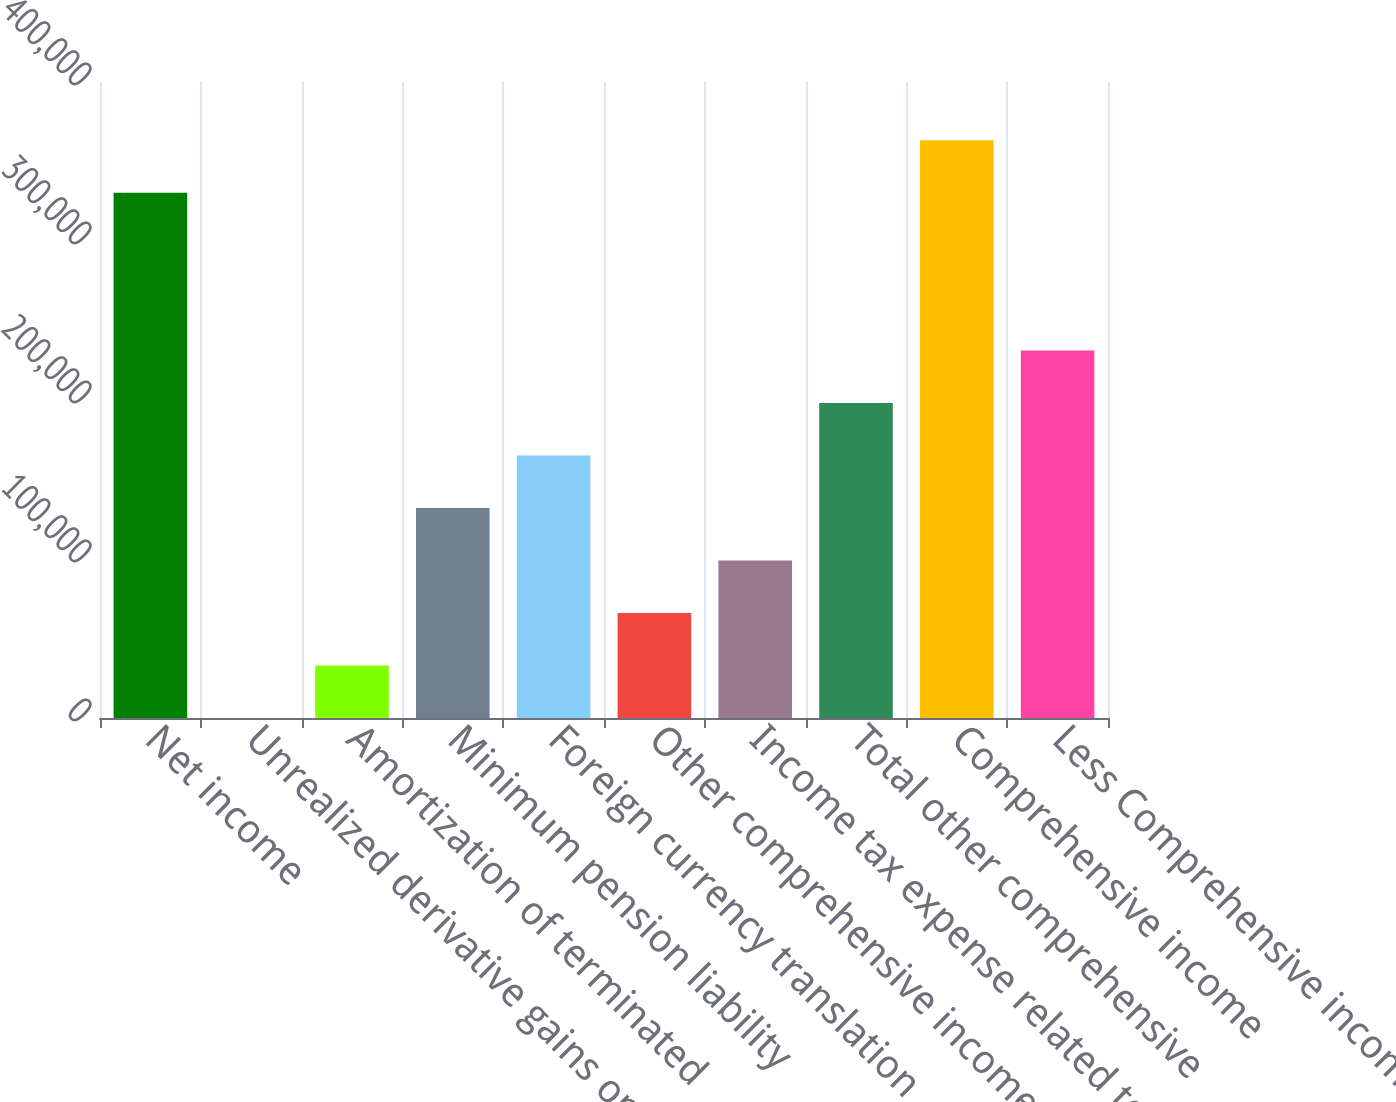Convert chart. <chart><loc_0><loc_0><loc_500><loc_500><bar_chart><fcel>Net income<fcel>Unrealized derivative gains on<fcel>Amortization of terminated<fcel>Minimum pension liability<fcel>Foreign currency translation<fcel>Other comprehensive income<fcel>Income tax expense related to<fcel>Total other comprehensive<fcel>Comprehensive income<fcel>Less Comprehensive income<nl><fcel>330278<fcel>0.43<fcel>33028.2<fcel>132111<fcel>165139<fcel>66055.9<fcel>99083.7<fcel>198167<fcel>363306<fcel>231195<nl></chart> 